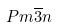Convert formula to latex. <formula><loc_0><loc_0><loc_500><loc_500>P m \overline { 3 } n</formula> 